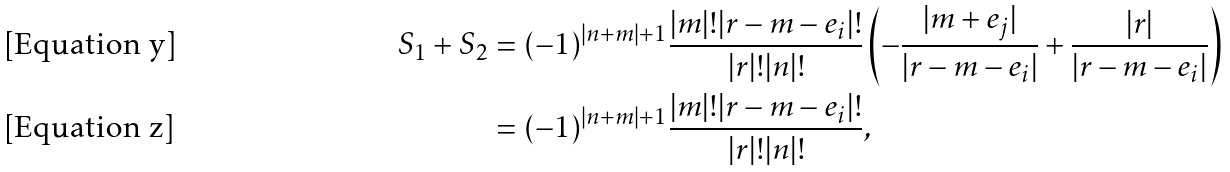<formula> <loc_0><loc_0><loc_500><loc_500>S _ { 1 } + S _ { 2 } & = ( - 1 ) ^ { | n + m | + 1 } \frac { | m | ! | r - m - e _ { i } | ! } { | r | ! | n | ! } \left ( - \frac { | m + e _ { j } | } { | r - m - e _ { i } | } + \frac { | r | } { | r - m - e _ { i } | } \right ) \\ & = ( - 1 ) ^ { | n + m | + 1 } \frac { | m | ! | r - m - e _ { i } | ! } { | r | ! | n | ! } ,</formula> 